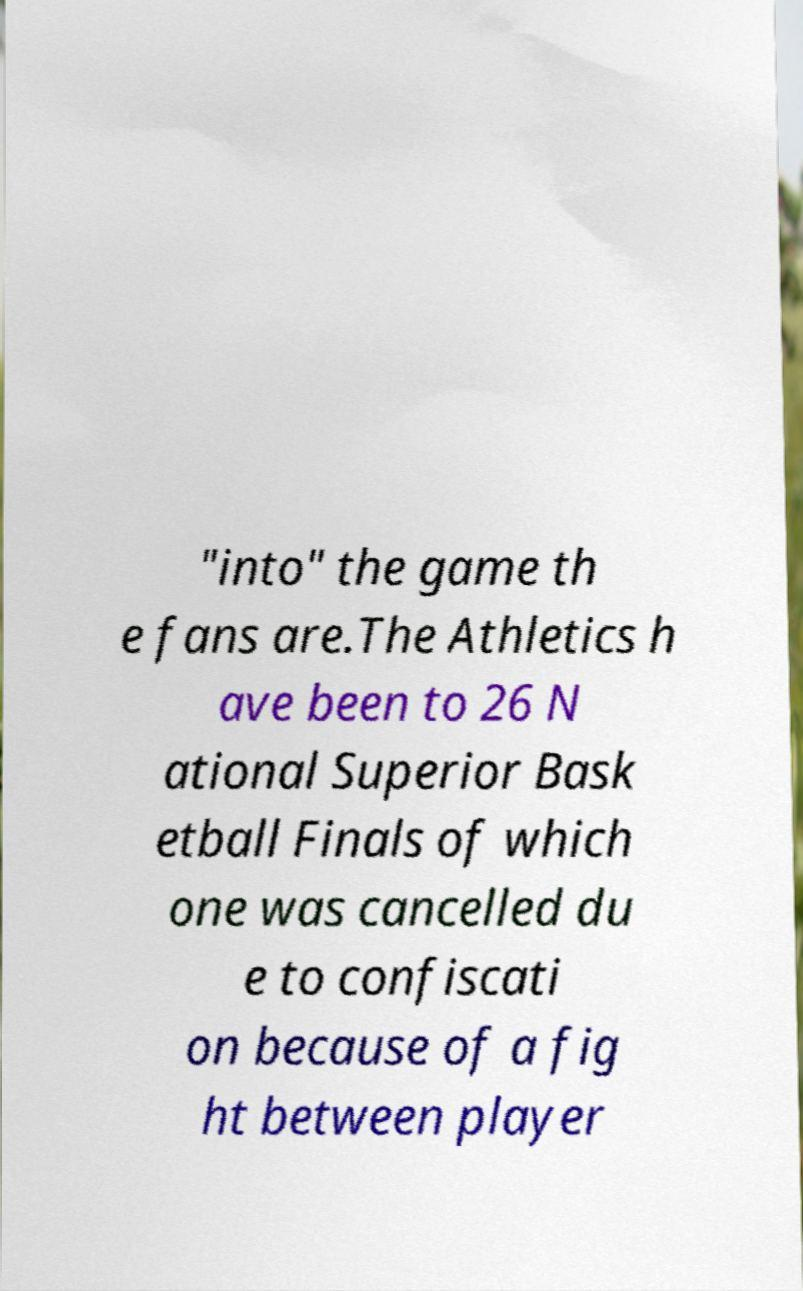I need the written content from this picture converted into text. Can you do that? "into" the game th e fans are.The Athletics h ave been to 26 N ational Superior Bask etball Finals of which one was cancelled du e to confiscati on because of a fig ht between player 